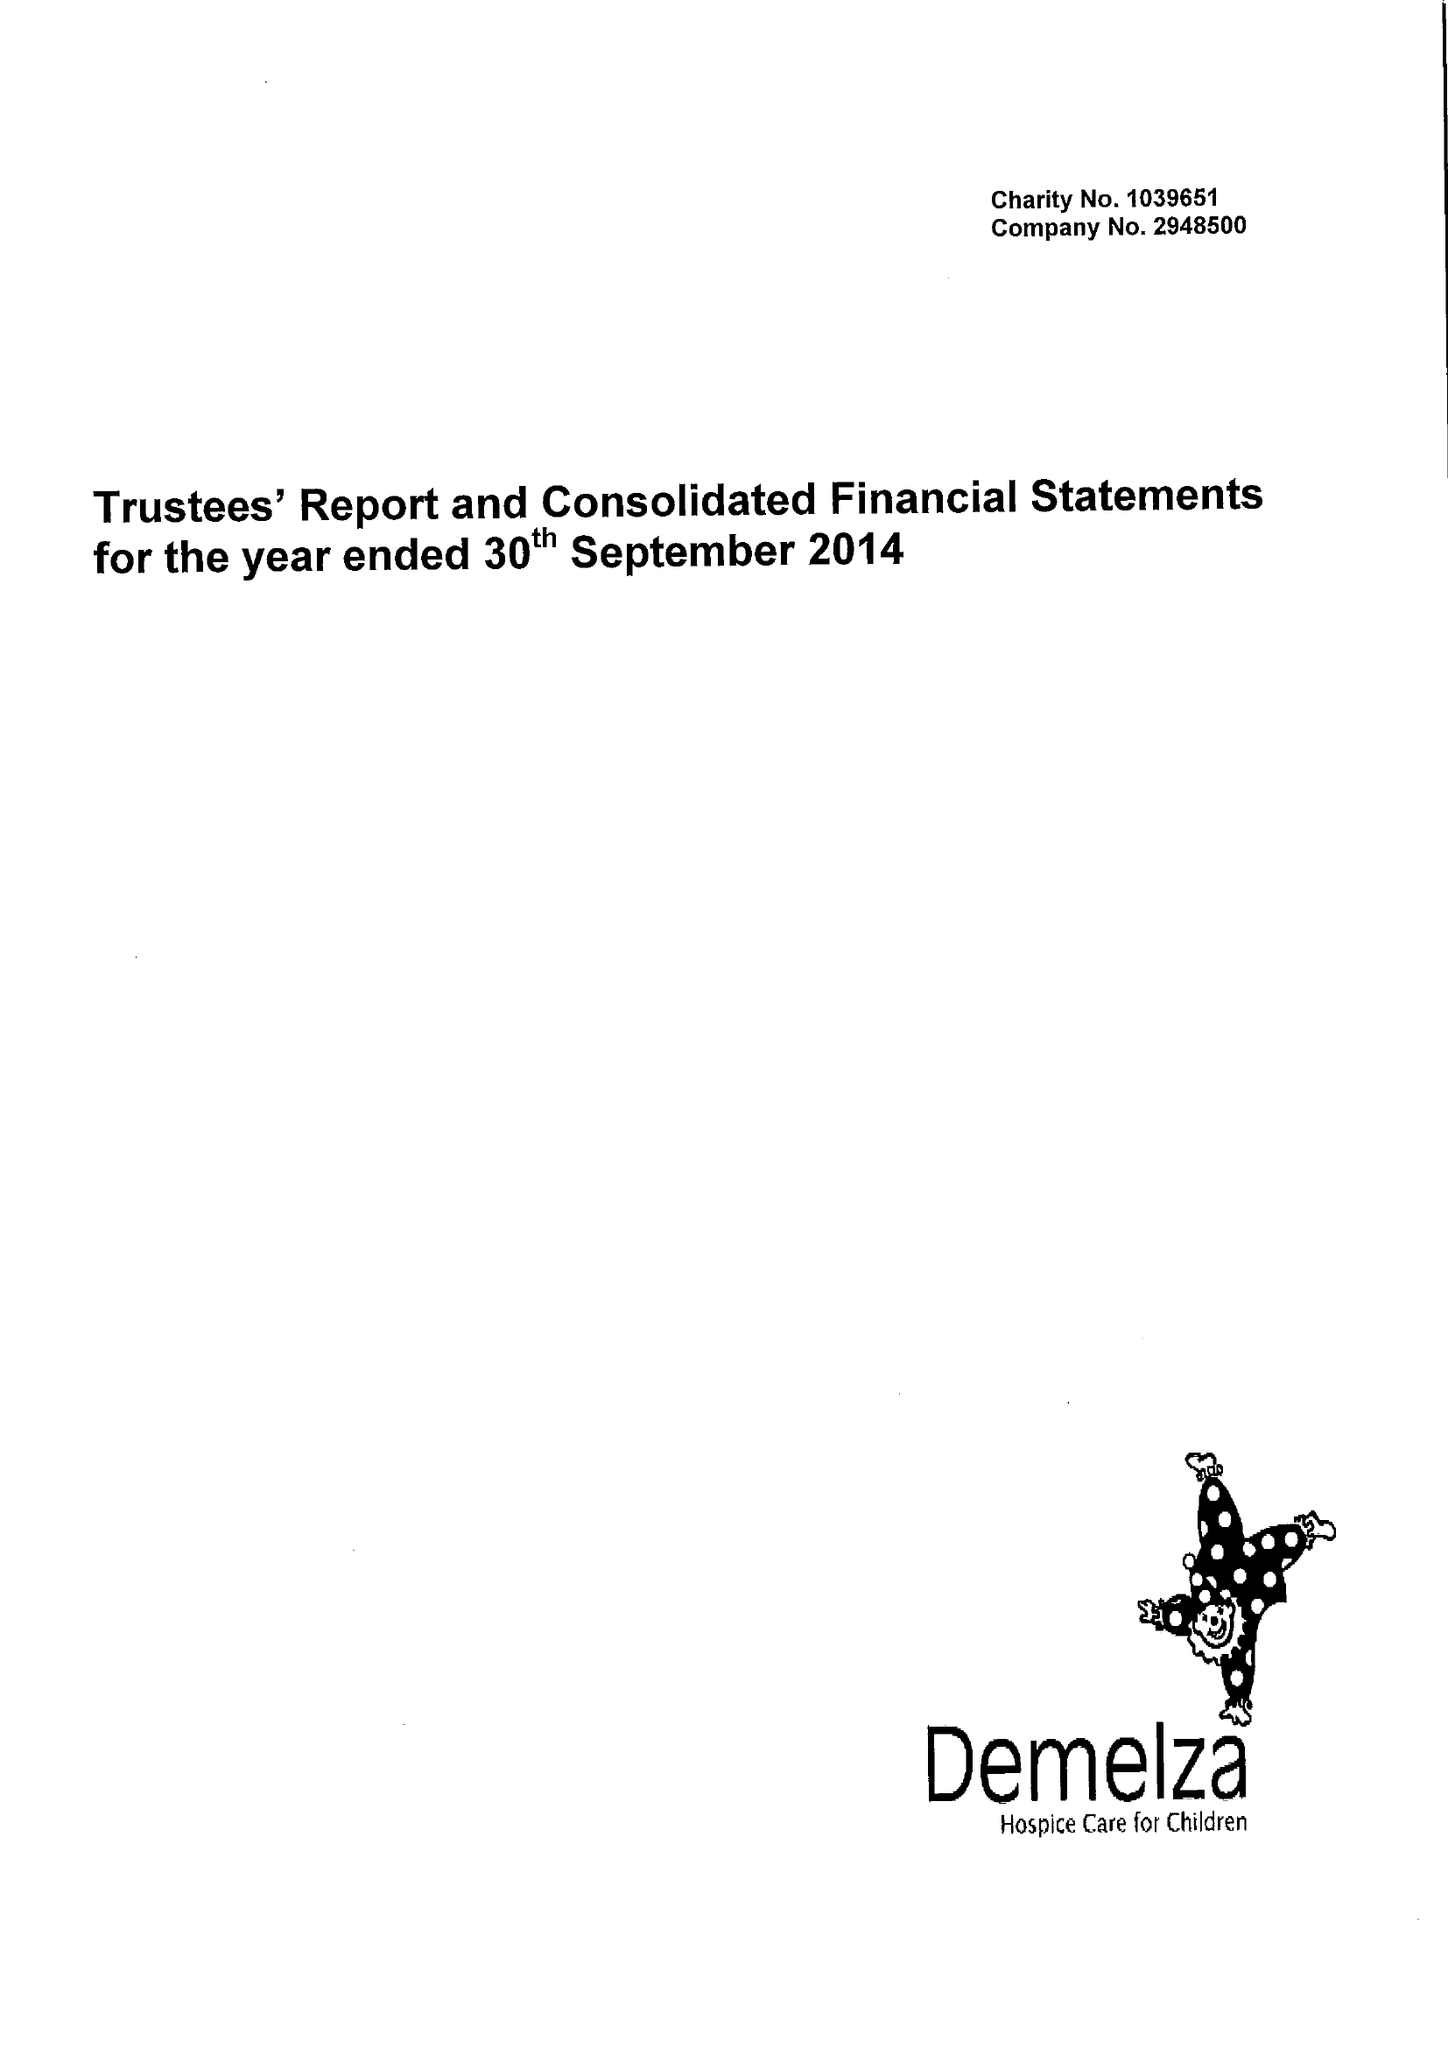What is the value for the report_date?
Answer the question using a single word or phrase. 2014-09-30 